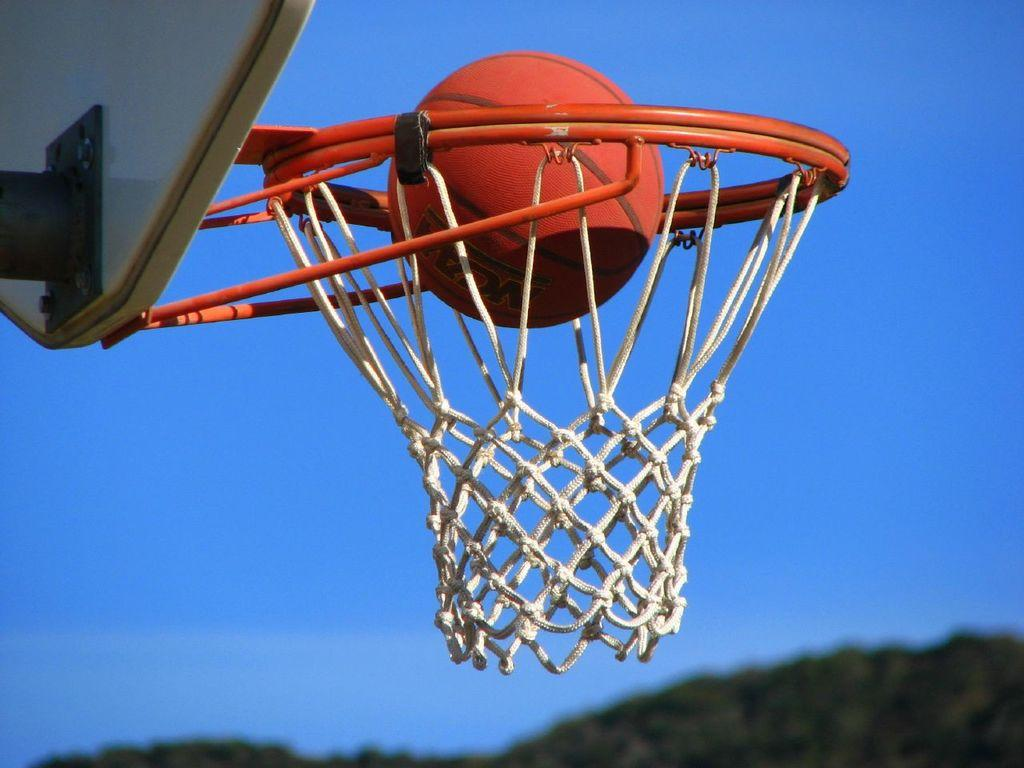What sports equipment is featured in the image? There is a basketball net, a basketball board, and a basketball in the image. What might be used to play the sport represented in the image? The basketball can be used to play the sport represented in the image. What can be seen in the background of the image? The sky is visible in the background of the image. What type of vegetation is present at the bottom of the image? There are trees at the bottom of the image. What time of day is it in the image, and how does the thrill of playing basketball change during the afternoon? The time of day is not mentioned in the image, and there is no indication of the thrill of playing basketball changing during the afternoon. 